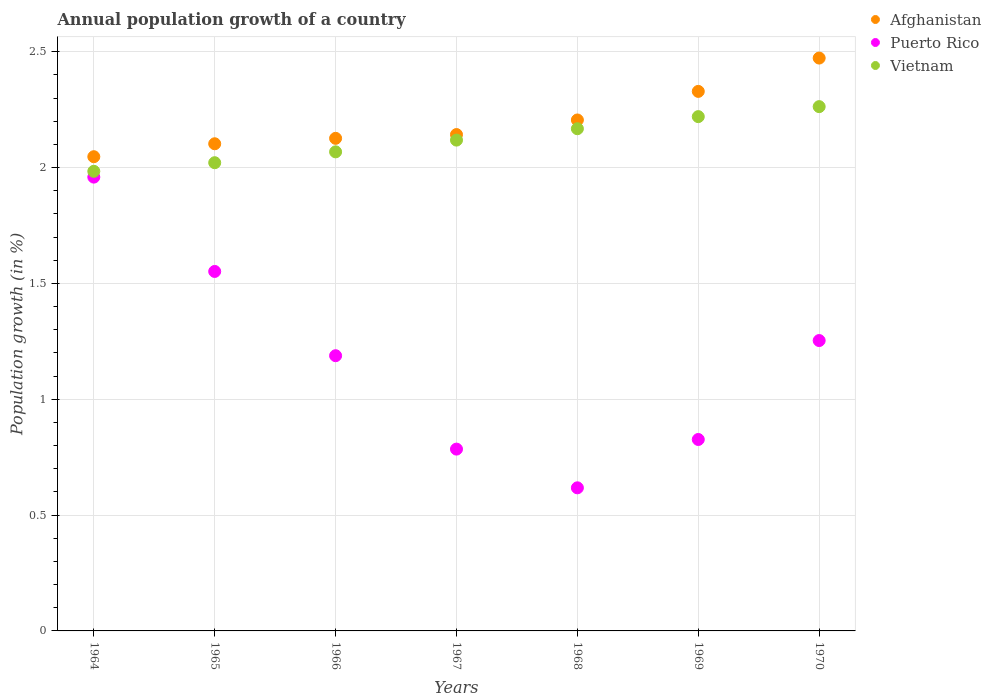How many different coloured dotlines are there?
Provide a short and direct response. 3. Is the number of dotlines equal to the number of legend labels?
Your response must be concise. Yes. What is the annual population growth in Afghanistan in 1970?
Ensure brevity in your answer.  2.47. Across all years, what is the maximum annual population growth in Afghanistan?
Your response must be concise. 2.47. Across all years, what is the minimum annual population growth in Vietnam?
Give a very brief answer. 1.98. In which year was the annual population growth in Afghanistan minimum?
Your answer should be compact. 1964. What is the total annual population growth in Afghanistan in the graph?
Offer a very short reply. 15.42. What is the difference between the annual population growth in Vietnam in 1966 and that in 1970?
Your answer should be compact. -0.2. What is the difference between the annual population growth in Afghanistan in 1967 and the annual population growth in Vietnam in 1970?
Ensure brevity in your answer.  -0.12. What is the average annual population growth in Puerto Rico per year?
Ensure brevity in your answer.  1.17. In the year 1964, what is the difference between the annual population growth in Vietnam and annual population growth in Puerto Rico?
Your response must be concise. 0.03. In how many years, is the annual population growth in Puerto Rico greater than 1.9 %?
Give a very brief answer. 1. What is the ratio of the annual population growth in Puerto Rico in 1965 to that in 1970?
Offer a terse response. 1.24. What is the difference between the highest and the second highest annual population growth in Afghanistan?
Your response must be concise. 0.14. What is the difference between the highest and the lowest annual population growth in Puerto Rico?
Make the answer very short. 1.34. In how many years, is the annual population growth in Afghanistan greater than the average annual population growth in Afghanistan taken over all years?
Offer a terse response. 3. Is the sum of the annual population growth in Puerto Rico in 1964 and 1970 greater than the maximum annual population growth in Vietnam across all years?
Your answer should be compact. Yes. Is the annual population growth in Afghanistan strictly greater than the annual population growth in Vietnam over the years?
Ensure brevity in your answer.  Yes. How many dotlines are there?
Keep it short and to the point. 3. How many years are there in the graph?
Your answer should be compact. 7. Are the values on the major ticks of Y-axis written in scientific E-notation?
Keep it short and to the point. No. Does the graph contain any zero values?
Offer a very short reply. No. Does the graph contain grids?
Offer a very short reply. Yes. Where does the legend appear in the graph?
Make the answer very short. Top right. How are the legend labels stacked?
Your answer should be very brief. Vertical. What is the title of the graph?
Provide a short and direct response. Annual population growth of a country. Does "Ukraine" appear as one of the legend labels in the graph?
Your response must be concise. No. What is the label or title of the Y-axis?
Give a very brief answer. Population growth (in %). What is the Population growth (in %) in Afghanistan in 1964?
Ensure brevity in your answer.  2.05. What is the Population growth (in %) of Puerto Rico in 1964?
Ensure brevity in your answer.  1.96. What is the Population growth (in %) in Vietnam in 1964?
Give a very brief answer. 1.98. What is the Population growth (in %) of Afghanistan in 1965?
Provide a succinct answer. 2.1. What is the Population growth (in %) in Puerto Rico in 1965?
Your answer should be very brief. 1.55. What is the Population growth (in %) in Vietnam in 1965?
Provide a succinct answer. 2.02. What is the Population growth (in %) in Afghanistan in 1966?
Your answer should be compact. 2.13. What is the Population growth (in %) of Puerto Rico in 1966?
Make the answer very short. 1.19. What is the Population growth (in %) of Vietnam in 1966?
Provide a succinct answer. 2.07. What is the Population growth (in %) in Afghanistan in 1967?
Your answer should be very brief. 2.14. What is the Population growth (in %) of Puerto Rico in 1967?
Keep it short and to the point. 0.78. What is the Population growth (in %) in Vietnam in 1967?
Offer a terse response. 2.12. What is the Population growth (in %) in Afghanistan in 1968?
Your response must be concise. 2.21. What is the Population growth (in %) of Puerto Rico in 1968?
Your response must be concise. 0.62. What is the Population growth (in %) of Vietnam in 1968?
Provide a short and direct response. 2.17. What is the Population growth (in %) of Afghanistan in 1969?
Ensure brevity in your answer.  2.33. What is the Population growth (in %) of Puerto Rico in 1969?
Your answer should be compact. 0.83. What is the Population growth (in %) of Vietnam in 1969?
Keep it short and to the point. 2.22. What is the Population growth (in %) in Afghanistan in 1970?
Offer a terse response. 2.47. What is the Population growth (in %) of Puerto Rico in 1970?
Keep it short and to the point. 1.25. What is the Population growth (in %) in Vietnam in 1970?
Offer a very short reply. 2.26. Across all years, what is the maximum Population growth (in %) in Afghanistan?
Keep it short and to the point. 2.47. Across all years, what is the maximum Population growth (in %) in Puerto Rico?
Offer a terse response. 1.96. Across all years, what is the maximum Population growth (in %) in Vietnam?
Your answer should be compact. 2.26. Across all years, what is the minimum Population growth (in %) in Afghanistan?
Give a very brief answer. 2.05. Across all years, what is the minimum Population growth (in %) of Puerto Rico?
Keep it short and to the point. 0.62. Across all years, what is the minimum Population growth (in %) of Vietnam?
Keep it short and to the point. 1.98. What is the total Population growth (in %) in Afghanistan in the graph?
Give a very brief answer. 15.42. What is the total Population growth (in %) in Puerto Rico in the graph?
Give a very brief answer. 8.18. What is the total Population growth (in %) in Vietnam in the graph?
Offer a very short reply. 14.84. What is the difference between the Population growth (in %) in Afghanistan in 1964 and that in 1965?
Keep it short and to the point. -0.06. What is the difference between the Population growth (in %) of Puerto Rico in 1964 and that in 1965?
Keep it short and to the point. 0.41. What is the difference between the Population growth (in %) of Vietnam in 1964 and that in 1965?
Make the answer very short. -0.04. What is the difference between the Population growth (in %) of Afghanistan in 1964 and that in 1966?
Make the answer very short. -0.08. What is the difference between the Population growth (in %) in Puerto Rico in 1964 and that in 1966?
Keep it short and to the point. 0.77. What is the difference between the Population growth (in %) in Vietnam in 1964 and that in 1966?
Offer a very short reply. -0.08. What is the difference between the Population growth (in %) in Afghanistan in 1964 and that in 1967?
Offer a very short reply. -0.1. What is the difference between the Population growth (in %) of Puerto Rico in 1964 and that in 1967?
Keep it short and to the point. 1.17. What is the difference between the Population growth (in %) in Vietnam in 1964 and that in 1967?
Your answer should be very brief. -0.13. What is the difference between the Population growth (in %) of Afghanistan in 1964 and that in 1968?
Keep it short and to the point. -0.16. What is the difference between the Population growth (in %) in Puerto Rico in 1964 and that in 1968?
Make the answer very short. 1.34. What is the difference between the Population growth (in %) in Vietnam in 1964 and that in 1968?
Your response must be concise. -0.18. What is the difference between the Population growth (in %) in Afghanistan in 1964 and that in 1969?
Ensure brevity in your answer.  -0.28. What is the difference between the Population growth (in %) in Puerto Rico in 1964 and that in 1969?
Make the answer very short. 1.13. What is the difference between the Population growth (in %) in Vietnam in 1964 and that in 1969?
Provide a succinct answer. -0.24. What is the difference between the Population growth (in %) in Afghanistan in 1964 and that in 1970?
Give a very brief answer. -0.43. What is the difference between the Population growth (in %) of Puerto Rico in 1964 and that in 1970?
Ensure brevity in your answer.  0.71. What is the difference between the Population growth (in %) in Vietnam in 1964 and that in 1970?
Your response must be concise. -0.28. What is the difference between the Population growth (in %) of Afghanistan in 1965 and that in 1966?
Give a very brief answer. -0.02. What is the difference between the Population growth (in %) in Puerto Rico in 1965 and that in 1966?
Provide a short and direct response. 0.36. What is the difference between the Population growth (in %) in Vietnam in 1965 and that in 1966?
Make the answer very short. -0.05. What is the difference between the Population growth (in %) in Afghanistan in 1965 and that in 1967?
Ensure brevity in your answer.  -0.04. What is the difference between the Population growth (in %) of Puerto Rico in 1965 and that in 1967?
Your answer should be very brief. 0.77. What is the difference between the Population growth (in %) in Vietnam in 1965 and that in 1967?
Ensure brevity in your answer.  -0.1. What is the difference between the Population growth (in %) in Afghanistan in 1965 and that in 1968?
Provide a short and direct response. -0.1. What is the difference between the Population growth (in %) in Puerto Rico in 1965 and that in 1968?
Your answer should be very brief. 0.93. What is the difference between the Population growth (in %) of Vietnam in 1965 and that in 1968?
Your response must be concise. -0.15. What is the difference between the Population growth (in %) of Afghanistan in 1965 and that in 1969?
Keep it short and to the point. -0.23. What is the difference between the Population growth (in %) of Puerto Rico in 1965 and that in 1969?
Your answer should be compact. 0.73. What is the difference between the Population growth (in %) of Vietnam in 1965 and that in 1969?
Your answer should be very brief. -0.2. What is the difference between the Population growth (in %) in Afghanistan in 1965 and that in 1970?
Ensure brevity in your answer.  -0.37. What is the difference between the Population growth (in %) in Puerto Rico in 1965 and that in 1970?
Make the answer very short. 0.3. What is the difference between the Population growth (in %) in Vietnam in 1965 and that in 1970?
Make the answer very short. -0.24. What is the difference between the Population growth (in %) of Afghanistan in 1966 and that in 1967?
Offer a terse response. -0.02. What is the difference between the Population growth (in %) in Puerto Rico in 1966 and that in 1967?
Your answer should be very brief. 0.4. What is the difference between the Population growth (in %) in Vietnam in 1966 and that in 1967?
Provide a short and direct response. -0.05. What is the difference between the Population growth (in %) in Afghanistan in 1966 and that in 1968?
Provide a succinct answer. -0.08. What is the difference between the Population growth (in %) in Puerto Rico in 1966 and that in 1968?
Provide a short and direct response. 0.57. What is the difference between the Population growth (in %) of Vietnam in 1966 and that in 1968?
Keep it short and to the point. -0.1. What is the difference between the Population growth (in %) of Afghanistan in 1966 and that in 1969?
Your answer should be compact. -0.2. What is the difference between the Population growth (in %) in Puerto Rico in 1966 and that in 1969?
Your answer should be compact. 0.36. What is the difference between the Population growth (in %) of Vietnam in 1966 and that in 1969?
Provide a succinct answer. -0.15. What is the difference between the Population growth (in %) in Afghanistan in 1966 and that in 1970?
Your answer should be compact. -0.35. What is the difference between the Population growth (in %) of Puerto Rico in 1966 and that in 1970?
Your response must be concise. -0.07. What is the difference between the Population growth (in %) in Vietnam in 1966 and that in 1970?
Your answer should be very brief. -0.2. What is the difference between the Population growth (in %) of Afghanistan in 1967 and that in 1968?
Offer a very short reply. -0.06. What is the difference between the Population growth (in %) in Puerto Rico in 1967 and that in 1968?
Your answer should be compact. 0.17. What is the difference between the Population growth (in %) of Vietnam in 1967 and that in 1968?
Your response must be concise. -0.05. What is the difference between the Population growth (in %) in Afghanistan in 1967 and that in 1969?
Offer a terse response. -0.19. What is the difference between the Population growth (in %) in Puerto Rico in 1967 and that in 1969?
Offer a very short reply. -0.04. What is the difference between the Population growth (in %) of Vietnam in 1967 and that in 1969?
Offer a terse response. -0.1. What is the difference between the Population growth (in %) of Afghanistan in 1967 and that in 1970?
Ensure brevity in your answer.  -0.33. What is the difference between the Population growth (in %) in Puerto Rico in 1967 and that in 1970?
Your answer should be very brief. -0.47. What is the difference between the Population growth (in %) in Vietnam in 1967 and that in 1970?
Provide a succinct answer. -0.14. What is the difference between the Population growth (in %) of Afghanistan in 1968 and that in 1969?
Make the answer very short. -0.12. What is the difference between the Population growth (in %) in Puerto Rico in 1968 and that in 1969?
Give a very brief answer. -0.21. What is the difference between the Population growth (in %) of Vietnam in 1968 and that in 1969?
Make the answer very short. -0.05. What is the difference between the Population growth (in %) in Afghanistan in 1968 and that in 1970?
Your answer should be compact. -0.27. What is the difference between the Population growth (in %) of Puerto Rico in 1968 and that in 1970?
Ensure brevity in your answer.  -0.64. What is the difference between the Population growth (in %) of Vietnam in 1968 and that in 1970?
Keep it short and to the point. -0.1. What is the difference between the Population growth (in %) in Afghanistan in 1969 and that in 1970?
Offer a very short reply. -0.14. What is the difference between the Population growth (in %) of Puerto Rico in 1969 and that in 1970?
Offer a very short reply. -0.43. What is the difference between the Population growth (in %) of Vietnam in 1969 and that in 1970?
Ensure brevity in your answer.  -0.04. What is the difference between the Population growth (in %) in Afghanistan in 1964 and the Population growth (in %) in Puerto Rico in 1965?
Make the answer very short. 0.5. What is the difference between the Population growth (in %) in Afghanistan in 1964 and the Population growth (in %) in Vietnam in 1965?
Provide a short and direct response. 0.03. What is the difference between the Population growth (in %) in Puerto Rico in 1964 and the Population growth (in %) in Vietnam in 1965?
Provide a succinct answer. -0.06. What is the difference between the Population growth (in %) of Afghanistan in 1964 and the Population growth (in %) of Puerto Rico in 1966?
Your answer should be compact. 0.86. What is the difference between the Population growth (in %) of Afghanistan in 1964 and the Population growth (in %) of Vietnam in 1966?
Provide a short and direct response. -0.02. What is the difference between the Population growth (in %) in Puerto Rico in 1964 and the Population growth (in %) in Vietnam in 1966?
Your answer should be compact. -0.11. What is the difference between the Population growth (in %) in Afghanistan in 1964 and the Population growth (in %) in Puerto Rico in 1967?
Your response must be concise. 1.26. What is the difference between the Population growth (in %) in Afghanistan in 1964 and the Population growth (in %) in Vietnam in 1967?
Provide a succinct answer. -0.07. What is the difference between the Population growth (in %) in Puerto Rico in 1964 and the Population growth (in %) in Vietnam in 1967?
Offer a terse response. -0.16. What is the difference between the Population growth (in %) in Afghanistan in 1964 and the Population growth (in %) in Puerto Rico in 1968?
Ensure brevity in your answer.  1.43. What is the difference between the Population growth (in %) of Afghanistan in 1964 and the Population growth (in %) of Vietnam in 1968?
Your answer should be very brief. -0.12. What is the difference between the Population growth (in %) of Puerto Rico in 1964 and the Population growth (in %) of Vietnam in 1968?
Make the answer very short. -0.21. What is the difference between the Population growth (in %) in Afghanistan in 1964 and the Population growth (in %) in Puerto Rico in 1969?
Provide a succinct answer. 1.22. What is the difference between the Population growth (in %) in Afghanistan in 1964 and the Population growth (in %) in Vietnam in 1969?
Provide a short and direct response. -0.17. What is the difference between the Population growth (in %) of Puerto Rico in 1964 and the Population growth (in %) of Vietnam in 1969?
Your answer should be very brief. -0.26. What is the difference between the Population growth (in %) of Afghanistan in 1964 and the Population growth (in %) of Puerto Rico in 1970?
Ensure brevity in your answer.  0.79. What is the difference between the Population growth (in %) of Afghanistan in 1964 and the Population growth (in %) of Vietnam in 1970?
Ensure brevity in your answer.  -0.22. What is the difference between the Population growth (in %) in Puerto Rico in 1964 and the Population growth (in %) in Vietnam in 1970?
Your answer should be compact. -0.3. What is the difference between the Population growth (in %) of Afghanistan in 1965 and the Population growth (in %) of Puerto Rico in 1966?
Offer a very short reply. 0.91. What is the difference between the Population growth (in %) of Afghanistan in 1965 and the Population growth (in %) of Vietnam in 1966?
Provide a short and direct response. 0.03. What is the difference between the Population growth (in %) of Puerto Rico in 1965 and the Population growth (in %) of Vietnam in 1966?
Ensure brevity in your answer.  -0.52. What is the difference between the Population growth (in %) in Afghanistan in 1965 and the Population growth (in %) in Puerto Rico in 1967?
Your response must be concise. 1.32. What is the difference between the Population growth (in %) of Afghanistan in 1965 and the Population growth (in %) of Vietnam in 1967?
Provide a succinct answer. -0.02. What is the difference between the Population growth (in %) in Puerto Rico in 1965 and the Population growth (in %) in Vietnam in 1967?
Provide a short and direct response. -0.57. What is the difference between the Population growth (in %) in Afghanistan in 1965 and the Population growth (in %) in Puerto Rico in 1968?
Make the answer very short. 1.48. What is the difference between the Population growth (in %) of Afghanistan in 1965 and the Population growth (in %) of Vietnam in 1968?
Offer a terse response. -0.06. What is the difference between the Population growth (in %) in Puerto Rico in 1965 and the Population growth (in %) in Vietnam in 1968?
Make the answer very short. -0.62. What is the difference between the Population growth (in %) of Afghanistan in 1965 and the Population growth (in %) of Puerto Rico in 1969?
Offer a terse response. 1.28. What is the difference between the Population growth (in %) in Afghanistan in 1965 and the Population growth (in %) in Vietnam in 1969?
Your answer should be very brief. -0.12. What is the difference between the Population growth (in %) in Puerto Rico in 1965 and the Population growth (in %) in Vietnam in 1969?
Give a very brief answer. -0.67. What is the difference between the Population growth (in %) of Afghanistan in 1965 and the Population growth (in %) of Puerto Rico in 1970?
Offer a terse response. 0.85. What is the difference between the Population growth (in %) of Afghanistan in 1965 and the Population growth (in %) of Vietnam in 1970?
Provide a succinct answer. -0.16. What is the difference between the Population growth (in %) of Puerto Rico in 1965 and the Population growth (in %) of Vietnam in 1970?
Keep it short and to the point. -0.71. What is the difference between the Population growth (in %) of Afghanistan in 1966 and the Population growth (in %) of Puerto Rico in 1967?
Your answer should be compact. 1.34. What is the difference between the Population growth (in %) of Afghanistan in 1966 and the Population growth (in %) of Vietnam in 1967?
Provide a short and direct response. 0.01. What is the difference between the Population growth (in %) of Puerto Rico in 1966 and the Population growth (in %) of Vietnam in 1967?
Offer a terse response. -0.93. What is the difference between the Population growth (in %) in Afghanistan in 1966 and the Population growth (in %) in Puerto Rico in 1968?
Give a very brief answer. 1.51. What is the difference between the Population growth (in %) of Afghanistan in 1966 and the Population growth (in %) of Vietnam in 1968?
Offer a terse response. -0.04. What is the difference between the Population growth (in %) in Puerto Rico in 1966 and the Population growth (in %) in Vietnam in 1968?
Provide a succinct answer. -0.98. What is the difference between the Population growth (in %) in Afghanistan in 1966 and the Population growth (in %) in Puerto Rico in 1969?
Provide a short and direct response. 1.3. What is the difference between the Population growth (in %) of Afghanistan in 1966 and the Population growth (in %) of Vietnam in 1969?
Your response must be concise. -0.09. What is the difference between the Population growth (in %) of Puerto Rico in 1966 and the Population growth (in %) of Vietnam in 1969?
Your answer should be very brief. -1.03. What is the difference between the Population growth (in %) of Afghanistan in 1966 and the Population growth (in %) of Puerto Rico in 1970?
Offer a very short reply. 0.87. What is the difference between the Population growth (in %) in Afghanistan in 1966 and the Population growth (in %) in Vietnam in 1970?
Make the answer very short. -0.14. What is the difference between the Population growth (in %) of Puerto Rico in 1966 and the Population growth (in %) of Vietnam in 1970?
Offer a very short reply. -1.07. What is the difference between the Population growth (in %) of Afghanistan in 1967 and the Population growth (in %) of Puerto Rico in 1968?
Keep it short and to the point. 1.52. What is the difference between the Population growth (in %) in Afghanistan in 1967 and the Population growth (in %) in Vietnam in 1968?
Make the answer very short. -0.03. What is the difference between the Population growth (in %) in Puerto Rico in 1967 and the Population growth (in %) in Vietnam in 1968?
Give a very brief answer. -1.38. What is the difference between the Population growth (in %) in Afghanistan in 1967 and the Population growth (in %) in Puerto Rico in 1969?
Your answer should be compact. 1.32. What is the difference between the Population growth (in %) of Afghanistan in 1967 and the Population growth (in %) of Vietnam in 1969?
Provide a succinct answer. -0.08. What is the difference between the Population growth (in %) in Puerto Rico in 1967 and the Population growth (in %) in Vietnam in 1969?
Offer a terse response. -1.44. What is the difference between the Population growth (in %) in Afghanistan in 1967 and the Population growth (in %) in Puerto Rico in 1970?
Make the answer very short. 0.89. What is the difference between the Population growth (in %) of Afghanistan in 1967 and the Population growth (in %) of Vietnam in 1970?
Your response must be concise. -0.12. What is the difference between the Population growth (in %) in Puerto Rico in 1967 and the Population growth (in %) in Vietnam in 1970?
Your answer should be very brief. -1.48. What is the difference between the Population growth (in %) in Afghanistan in 1968 and the Population growth (in %) in Puerto Rico in 1969?
Your answer should be compact. 1.38. What is the difference between the Population growth (in %) in Afghanistan in 1968 and the Population growth (in %) in Vietnam in 1969?
Ensure brevity in your answer.  -0.01. What is the difference between the Population growth (in %) of Puerto Rico in 1968 and the Population growth (in %) of Vietnam in 1969?
Ensure brevity in your answer.  -1.6. What is the difference between the Population growth (in %) in Afghanistan in 1968 and the Population growth (in %) in Vietnam in 1970?
Your answer should be very brief. -0.06. What is the difference between the Population growth (in %) in Puerto Rico in 1968 and the Population growth (in %) in Vietnam in 1970?
Provide a succinct answer. -1.65. What is the difference between the Population growth (in %) of Afghanistan in 1969 and the Population growth (in %) of Puerto Rico in 1970?
Make the answer very short. 1.08. What is the difference between the Population growth (in %) in Afghanistan in 1969 and the Population growth (in %) in Vietnam in 1970?
Offer a terse response. 0.07. What is the difference between the Population growth (in %) of Puerto Rico in 1969 and the Population growth (in %) of Vietnam in 1970?
Ensure brevity in your answer.  -1.44. What is the average Population growth (in %) in Afghanistan per year?
Provide a short and direct response. 2.2. What is the average Population growth (in %) in Puerto Rico per year?
Offer a terse response. 1.17. What is the average Population growth (in %) of Vietnam per year?
Make the answer very short. 2.12. In the year 1964, what is the difference between the Population growth (in %) in Afghanistan and Population growth (in %) in Puerto Rico?
Your answer should be compact. 0.09. In the year 1964, what is the difference between the Population growth (in %) in Afghanistan and Population growth (in %) in Vietnam?
Provide a succinct answer. 0.06. In the year 1964, what is the difference between the Population growth (in %) of Puerto Rico and Population growth (in %) of Vietnam?
Ensure brevity in your answer.  -0.03. In the year 1965, what is the difference between the Population growth (in %) in Afghanistan and Population growth (in %) in Puerto Rico?
Your response must be concise. 0.55. In the year 1965, what is the difference between the Population growth (in %) in Afghanistan and Population growth (in %) in Vietnam?
Keep it short and to the point. 0.08. In the year 1965, what is the difference between the Population growth (in %) in Puerto Rico and Population growth (in %) in Vietnam?
Offer a terse response. -0.47. In the year 1966, what is the difference between the Population growth (in %) in Afghanistan and Population growth (in %) in Puerto Rico?
Ensure brevity in your answer.  0.94. In the year 1966, what is the difference between the Population growth (in %) in Afghanistan and Population growth (in %) in Vietnam?
Make the answer very short. 0.06. In the year 1966, what is the difference between the Population growth (in %) of Puerto Rico and Population growth (in %) of Vietnam?
Offer a terse response. -0.88. In the year 1967, what is the difference between the Population growth (in %) of Afghanistan and Population growth (in %) of Puerto Rico?
Provide a short and direct response. 1.36. In the year 1967, what is the difference between the Population growth (in %) of Afghanistan and Population growth (in %) of Vietnam?
Your answer should be compact. 0.02. In the year 1967, what is the difference between the Population growth (in %) in Puerto Rico and Population growth (in %) in Vietnam?
Keep it short and to the point. -1.33. In the year 1968, what is the difference between the Population growth (in %) of Afghanistan and Population growth (in %) of Puerto Rico?
Make the answer very short. 1.59. In the year 1968, what is the difference between the Population growth (in %) in Afghanistan and Population growth (in %) in Vietnam?
Your response must be concise. 0.04. In the year 1968, what is the difference between the Population growth (in %) in Puerto Rico and Population growth (in %) in Vietnam?
Offer a terse response. -1.55. In the year 1969, what is the difference between the Population growth (in %) of Afghanistan and Population growth (in %) of Puerto Rico?
Keep it short and to the point. 1.5. In the year 1969, what is the difference between the Population growth (in %) in Afghanistan and Population growth (in %) in Vietnam?
Your answer should be very brief. 0.11. In the year 1969, what is the difference between the Population growth (in %) of Puerto Rico and Population growth (in %) of Vietnam?
Your response must be concise. -1.39. In the year 1970, what is the difference between the Population growth (in %) in Afghanistan and Population growth (in %) in Puerto Rico?
Keep it short and to the point. 1.22. In the year 1970, what is the difference between the Population growth (in %) in Afghanistan and Population growth (in %) in Vietnam?
Provide a succinct answer. 0.21. In the year 1970, what is the difference between the Population growth (in %) of Puerto Rico and Population growth (in %) of Vietnam?
Offer a terse response. -1.01. What is the ratio of the Population growth (in %) of Afghanistan in 1964 to that in 1965?
Your response must be concise. 0.97. What is the ratio of the Population growth (in %) of Puerto Rico in 1964 to that in 1965?
Make the answer very short. 1.26. What is the ratio of the Population growth (in %) in Vietnam in 1964 to that in 1965?
Give a very brief answer. 0.98. What is the ratio of the Population growth (in %) of Afghanistan in 1964 to that in 1966?
Provide a short and direct response. 0.96. What is the ratio of the Population growth (in %) in Puerto Rico in 1964 to that in 1966?
Your answer should be compact. 1.65. What is the ratio of the Population growth (in %) in Vietnam in 1964 to that in 1966?
Give a very brief answer. 0.96. What is the ratio of the Population growth (in %) of Afghanistan in 1964 to that in 1967?
Your response must be concise. 0.96. What is the ratio of the Population growth (in %) of Puerto Rico in 1964 to that in 1967?
Provide a succinct answer. 2.5. What is the ratio of the Population growth (in %) of Vietnam in 1964 to that in 1967?
Your answer should be compact. 0.94. What is the ratio of the Population growth (in %) of Afghanistan in 1964 to that in 1968?
Your response must be concise. 0.93. What is the ratio of the Population growth (in %) of Puerto Rico in 1964 to that in 1968?
Your response must be concise. 3.17. What is the ratio of the Population growth (in %) in Vietnam in 1964 to that in 1968?
Your response must be concise. 0.92. What is the ratio of the Population growth (in %) in Afghanistan in 1964 to that in 1969?
Your answer should be very brief. 0.88. What is the ratio of the Population growth (in %) of Puerto Rico in 1964 to that in 1969?
Give a very brief answer. 2.37. What is the ratio of the Population growth (in %) in Vietnam in 1964 to that in 1969?
Provide a succinct answer. 0.89. What is the ratio of the Population growth (in %) in Afghanistan in 1964 to that in 1970?
Your response must be concise. 0.83. What is the ratio of the Population growth (in %) of Puerto Rico in 1964 to that in 1970?
Offer a terse response. 1.56. What is the ratio of the Population growth (in %) of Vietnam in 1964 to that in 1970?
Keep it short and to the point. 0.88. What is the ratio of the Population growth (in %) of Afghanistan in 1965 to that in 1966?
Offer a very short reply. 0.99. What is the ratio of the Population growth (in %) of Puerto Rico in 1965 to that in 1966?
Keep it short and to the point. 1.31. What is the ratio of the Population growth (in %) in Vietnam in 1965 to that in 1966?
Provide a short and direct response. 0.98. What is the ratio of the Population growth (in %) of Afghanistan in 1965 to that in 1967?
Offer a terse response. 0.98. What is the ratio of the Population growth (in %) in Puerto Rico in 1965 to that in 1967?
Make the answer very short. 1.98. What is the ratio of the Population growth (in %) in Vietnam in 1965 to that in 1967?
Provide a succinct answer. 0.95. What is the ratio of the Population growth (in %) of Afghanistan in 1965 to that in 1968?
Offer a very short reply. 0.95. What is the ratio of the Population growth (in %) in Puerto Rico in 1965 to that in 1968?
Provide a short and direct response. 2.51. What is the ratio of the Population growth (in %) in Vietnam in 1965 to that in 1968?
Your answer should be compact. 0.93. What is the ratio of the Population growth (in %) in Afghanistan in 1965 to that in 1969?
Your answer should be very brief. 0.9. What is the ratio of the Population growth (in %) in Puerto Rico in 1965 to that in 1969?
Provide a short and direct response. 1.88. What is the ratio of the Population growth (in %) in Vietnam in 1965 to that in 1969?
Give a very brief answer. 0.91. What is the ratio of the Population growth (in %) of Afghanistan in 1965 to that in 1970?
Offer a terse response. 0.85. What is the ratio of the Population growth (in %) in Puerto Rico in 1965 to that in 1970?
Offer a terse response. 1.24. What is the ratio of the Population growth (in %) of Vietnam in 1965 to that in 1970?
Your answer should be compact. 0.89. What is the ratio of the Population growth (in %) in Puerto Rico in 1966 to that in 1967?
Your response must be concise. 1.51. What is the ratio of the Population growth (in %) in Vietnam in 1966 to that in 1967?
Give a very brief answer. 0.98. What is the ratio of the Population growth (in %) of Afghanistan in 1966 to that in 1968?
Ensure brevity in your answer.  0.96. What is the ratio of the Population growth (in %) of Puerto Rico in 1966 to that in 1968?
Your answer should be compact. 1.92. What is the ratio of the Population growth (in %) of Vietnam in 1966 to that in 1968?
Provide a short and direct response. 0.95. What is the ratio of the Population growth (in %) of Puerto Rico in 1966 to that in 1969?
Provide a short and direct response. 1.44. What is the ratio of the Population growth (in %) of Vietnam in 1966 to that in 1969?
Your answer should be very brief. 0.93. What is the ratio of the Population growth (in %) of Afghanistan in 1966 to that in 1970?
Keep it short and to the point. 0.86. What is the ratio of the Population growth (in %) of Puerto Rico in 1966 to that in 1970?
Your response must be concise. 0.95. What is the ratio of the Population growth (in %) in Vietnam in 1966 to that in 1970?
Your response must be concise. 0.91. What is the ratio of the Population growth (in %) of Afghanistan in 1967 to that in 1968?
Make the answer very short. 0.97. What is the ratio of the Population growth (in %) in Puerto Rico in 1967 to that in 1968?
Give a very brief answer. 1.27. What is the ratio of the Population growth (in %) of Vietnam in 1967 to that in 1968?
Ensure brevity in your answer.  0.98. What is the ratio of the Population growth (in %) of Puerto Rico in 1967 to that in 1969?
Ensure brevity in your answer.  0.95. What is the ratio of the Population growth (in %) in Vietnam in 1967 to that in 1969?
Keep it short and to the point. 0.95. What is the ratio of the Population growth (in %) in Afghanistan in 1967 to that in 1970?
Your answer should be very brief. 0.87. What is the ratio of the Population growth (in %) of Puerto Rico in 1967 to that in 1970?
Provide a short and direct response. 0.63. What is the ratio of the Population growth (in %) in Vietnam in 1967 to that in 1970?
Your response must be concise. 0.94. What is the ratio of the Population growth (in %) in Afghanistan in 1968 to that in 1969?
Ensure brevity in your answer.  0.95. What is the ratio of the Population growth (in %) of Puerto Rico in 1968 to that in 1969?
Your answer should be very brief. 0.75. What is the ratio of the Population growth (in %) of Vietnam in 1968 to that in 1969?
Offer a very short reply. 0.98. What is the ratio of the Population growth (in %) of Afghanistan in 1968 to that in 1970?
Give a very brief answer. 0.89. What is the ratio of the Population growth (in %) of Puerto Rico in 1968 to that in 1970?
Your answer should be compact. 0.49. What is the ratio of the Population growth (in %) in Vietnam in 1968 to that in 1970?
Make the answer very short. 0.96. What is the ratio of the Population growth (in %) of Afghanistan in 1969 to that in 1970?
Keep it short and to the point. 0.94. What is the ratio of the Population growth (in %) of Puerto Rico in 1969 to that in 1970?
Offer a very short reply. 0.66. What is the ratio of the Population growth (in %) of Vietnam in 1969 to that in 1970?
Make the answer very short. 0.98. What is the difference between the highest and the second highest Population growth (in %) in Afghanistan?
Ensure brevity in your answer.  0.14. What is the difference between the highest and the second highest Population growth (in %) in Puerto Rico?
Ensure brevity in your answer.  0.41. What is the difference between the highest and the second highest Population growth (in %) in Vietnam?
Make the answer very short. 0.04. What is the difference between the highest and the lowest Population growth (in %) in Afghanistan?
Ensure brevity in your answer.  0.43. What is the difference between the highest and the lowest Population growth (in %) in Puerto Rico?
Your answer should be compact. 1.34. What is the difference between the highest and the lowest Population growth (in %) of Vietnam?
Your answer should be compact. 0.28. 